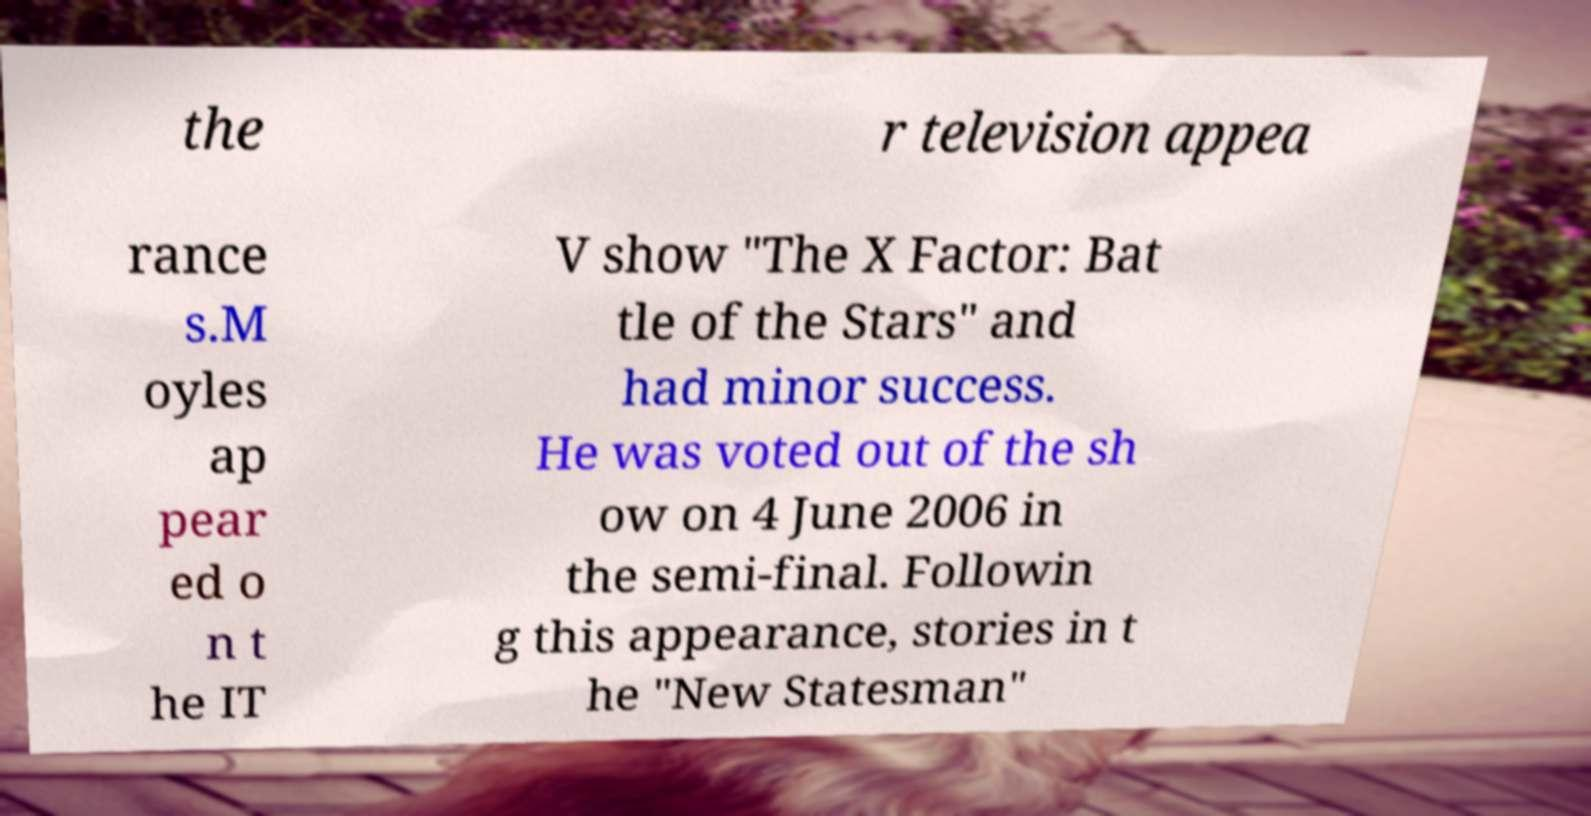For documentation purposes, I need the text within this image transcribed. Could you provide that? the r television appea rance s.M oyles ap pear ed o n t he IT V show "The X Factor: Bat tle of the Stars" and had minor success. He was voted out of the sh ow on 4 June 2006 in the semi-final. Followin g this appearance, stories in t he "New Statesman" 